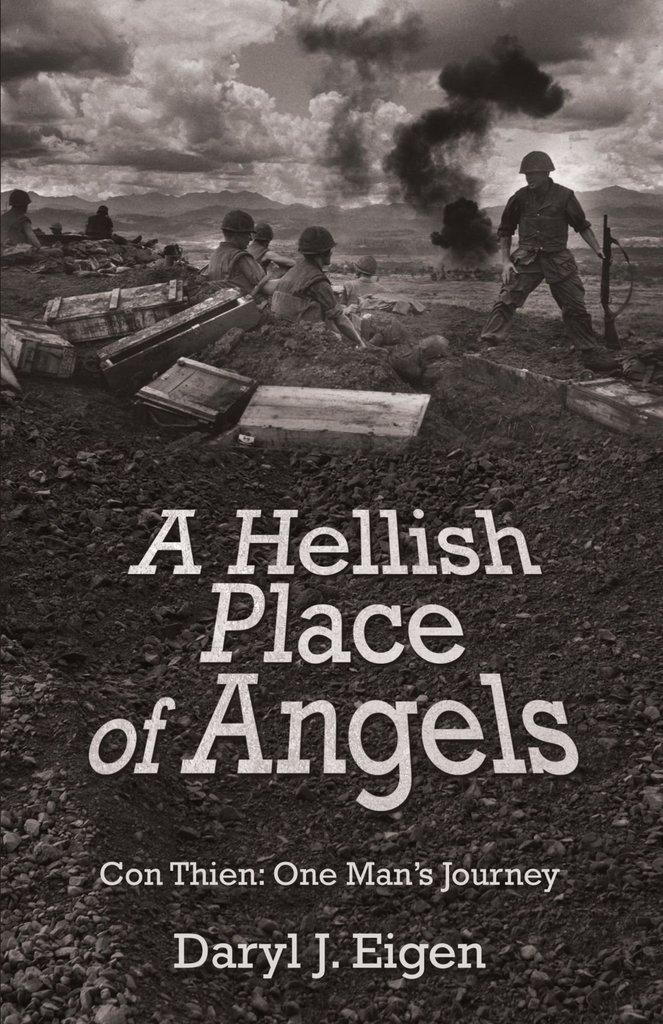<image>
Write a terse but informative summary of the picture. a book that has the word angels on it 